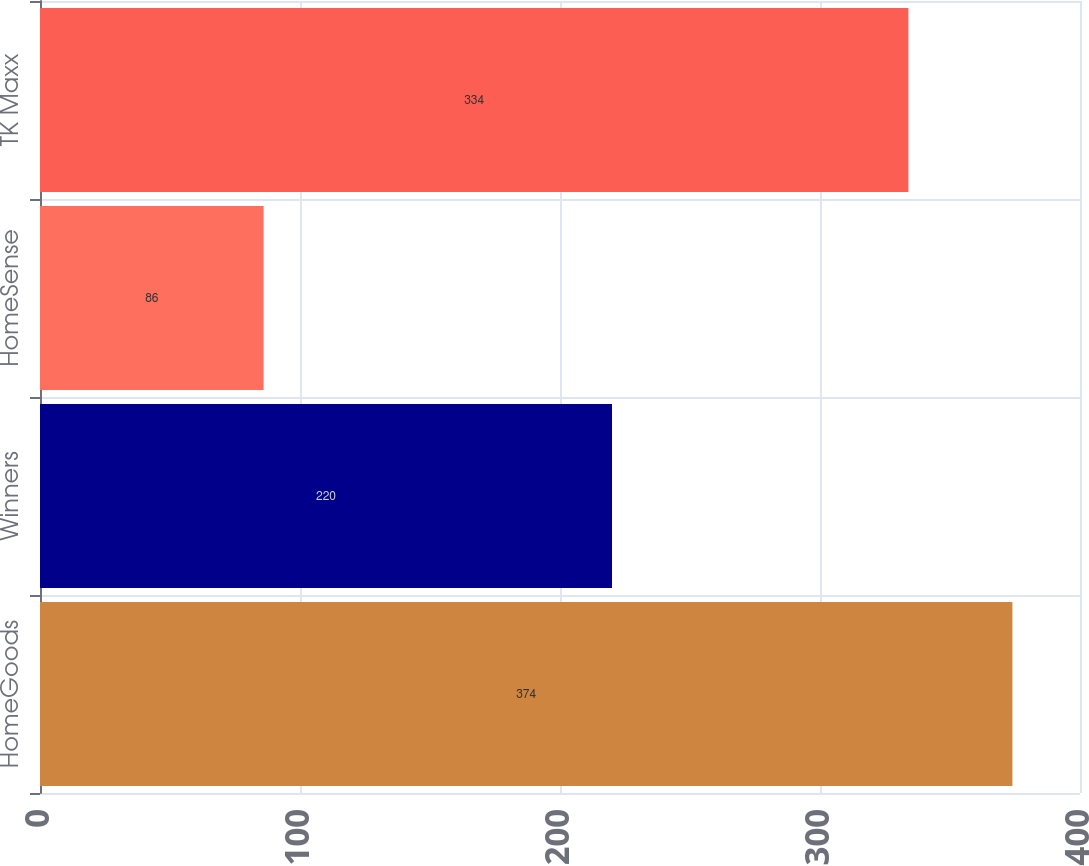Convert chart to OTSL. <chart><loc_0><loc_0><loc_500><loc_500><bar_chart><fcel>HomeGoods<fcel>Winners<fcel>HomeSense<fcel>TK Maxx<nl><fcel>374<fcel>220<fcel>86<fcel>334<nl></chart> 